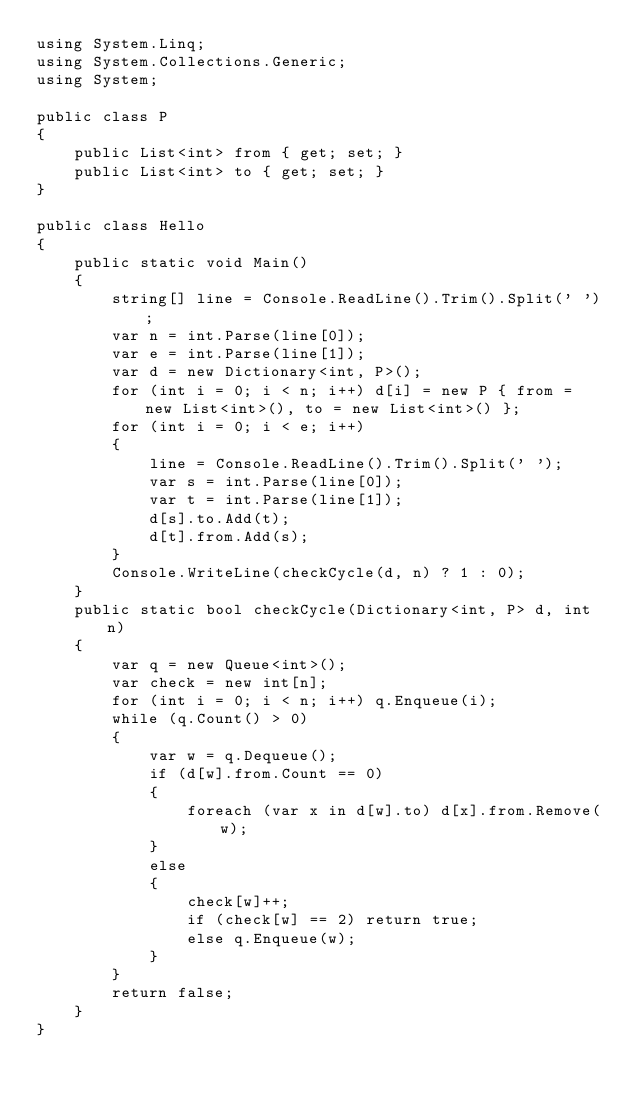Convert code to text. <code><loc_0><loc_0><loc_500><loc_500><_C#_>using System.Linq;
using System.Collections.Generic;
using System;

public class P
{
    public List<int> from { get; set; }
    public List<int> to { get; set; }
}

public class Hello
{
    public static void Main()
    {
        string[] line = Console.ReadLine().Trim().Split(' ');
        var n = int.Parse(line[0]);
        var e = int.Parse(line[1]);
        var d = new Dictionary<int, P>();
        for (int i = 0; i < n; i++) d[i] = new P { from = new List<int>(), to = new List<int>() };
        for (int i = 0; i < e; i++)
        {
            line = Console.ReadLine().Trim().Split(' ');
            var s = int.Parse(line[0]);
            var t = int.Parse(line[1]);
            d[s].to.Add(t);
            d[t].from.Add(s);
        }
        Console.WriteLine(checkCycle(d, n) ? 1 : 0);
    }
    public static bool checkCycle(Dictionary<int, P> d, int n)
    {
        var q = new Queue<int>();
        var check = new int[n];
        for (int i = 0; i < n; i++) q.Enqueue(i);
        while (q.Count() > 0)
        {
            var w = q.Dequeue();
            if (d[w].from.Count == 0)
            {
                foreach (var x in d[w].to) d[x].from.Remove(w);
            }
            else
            {
                check[w]++;
                if (check[w] == 2) return true;
                else q.Enqueue(w);
            }
        }
        return false;
    }
}


</code> 